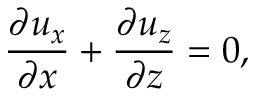<formula> <loc_0><loc_0><loc_500><loc_500>\frac { \partial u _ { x } } { \partial x } + \frac { \partial u _ { z } } { \partial z } = 0 ,</formula> 